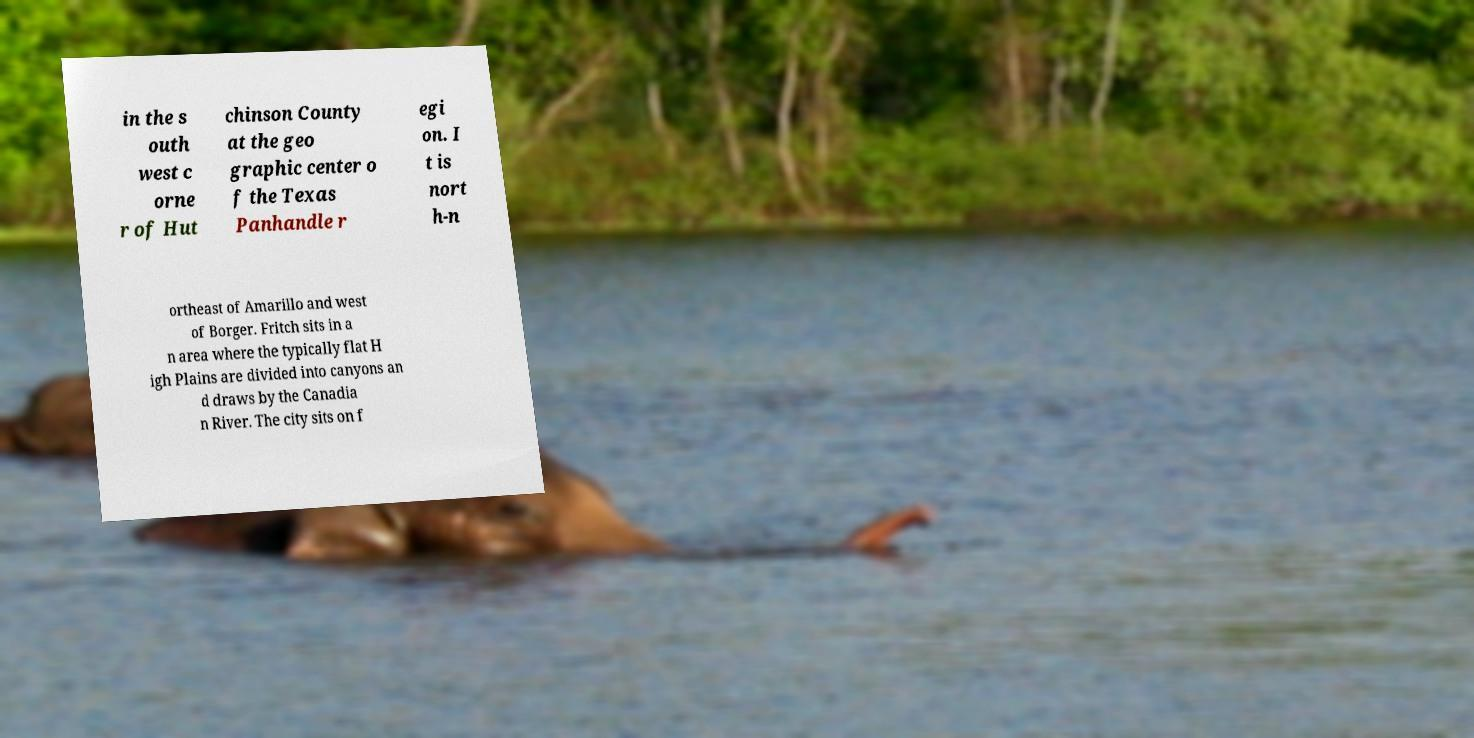There's text embedded in this image that I need extracted. Can you transcribe it verbatim? in the s outh west c orne r of Hut chinson County at the geo graphic center o f the Texas Panhandle r egi on. I t is nort h-n ortheast of Amarillo and west of Borger. Fritch sits in a n area where the typically flat H igh Plains are divided into canyons an d draws by the Canadia n River. The city sits on f 